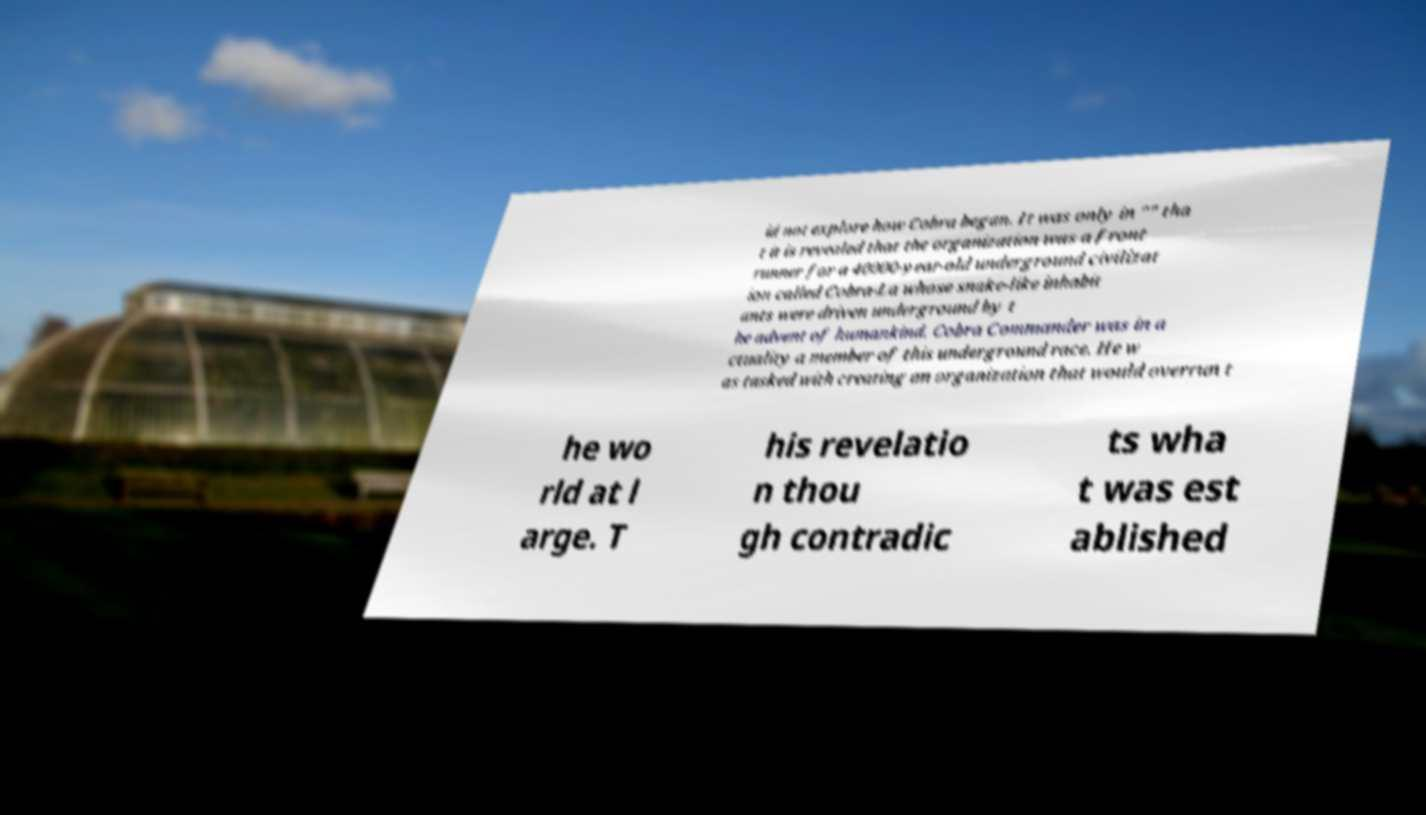I need the written content from this picture converted into text. Can you do that? id not explore how Cobra began. It was only in "" tha t it is revealed that the organization was a front runner for a 40000-year-old underground civilizat ion called Cobra-La whose snake-like inhabit ants were driven underground by t he advent of humankind. Cobra Commander was in a ctuality a member of this underground race. He w as tasked with creating an organization that would overrun t he wo rld at l arge. T his revelatio n thou gh contradic ts wha t was est ablished 